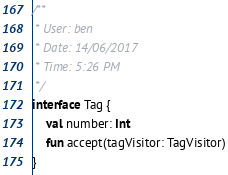<code> <loc_0><loc_0><loc_500><loc_500><_Kotlin_>
/**
 * User: ben
 * Date: 14/06/2017
 * Time: 5:26 PM
 */
interface Tag {
    val number: Int
    fun accept(tagVisitor: TagVisitor)
}
</code> 